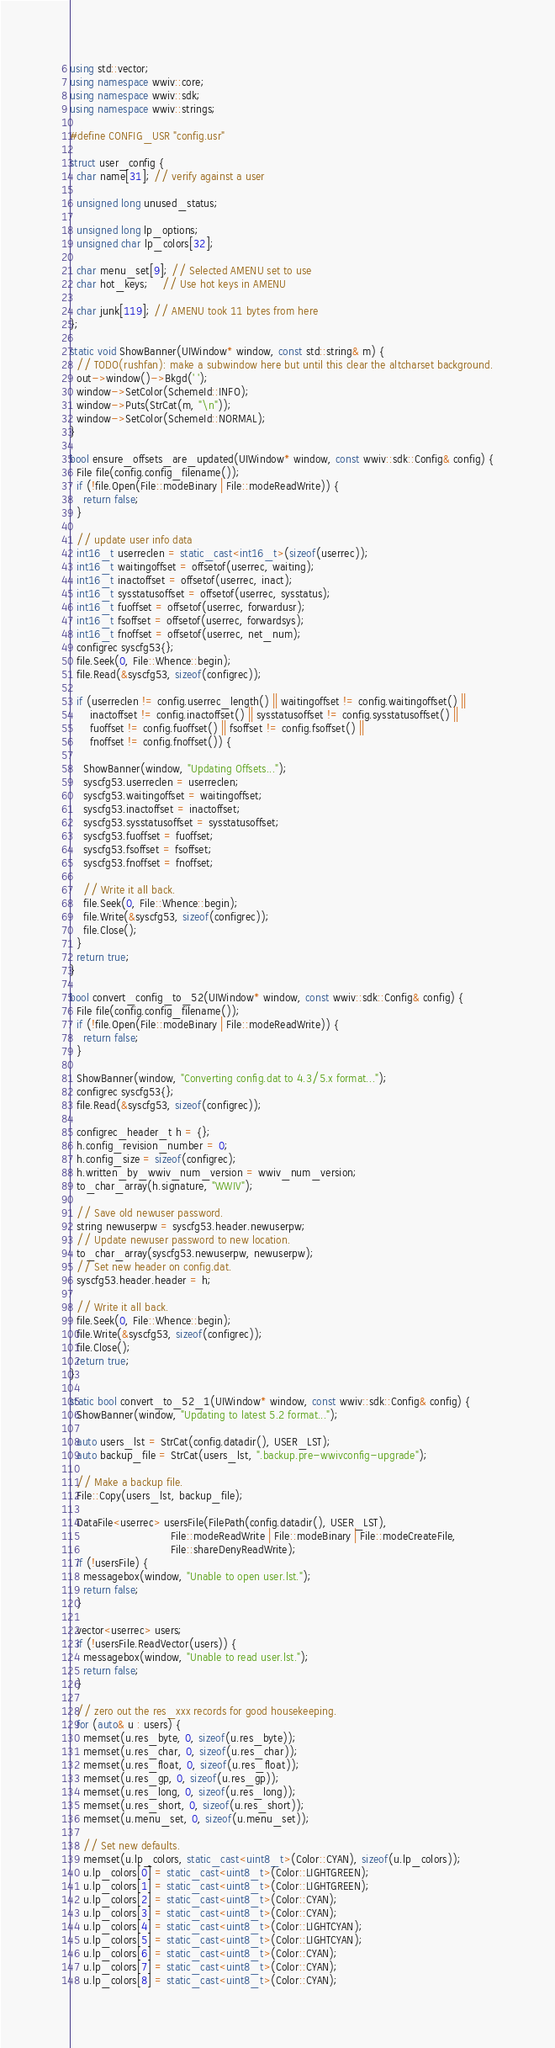<code> <loc_0><loc_0><loc_500><loc_500><_C++_>using std::vector;
using namespace wwiv::core;
using namespace wwiv::sdk;
using namespace wwiv::strings;

#define CONFIG_USR "config.usr"

struct user_config {
  char name[31]; // verify against a user

  unsigned long unused_status;

  unsigned long lp_options;
  unsigned char lp_colors[32];

  char menu_set[9]; // Selected AMENU set to use
  char hot_keys;    // Use hot keys in AMENU

  char junk[119]; // AMENU took 11 bytes from here
};

static void ShowBanner(UIWindow* window, const std::string& m) {
  // TODO(rushfan): make a subwindow here but until this clear the altcharset background.
  out->window()->Bkgd(' ');
  window->SetColor(SchemeId::INFO);
  window->Puts(StrCat(m, "\n"));
  window->SetColor(SchemeId::NORMAL);
}

bool ensure_offsets_are_updated(UIWindow* window, const wwiv::sdk::Config& config) {
  File file(config.config_filename());
  if (!file.Open(File::modeBinary | File::modeReadWrite)) {
    return false;
  }

  // update user info data
  int16_t userreclen = static_cast<int16_t>(sizeof(userrec));
  int16_t waitingoffset = offsetof(userrec, waiting);
  int16_t inactoffset = offsetof(userrec, inact);
  int16_t sysstatusoffset = offsetof(userrec, sysstatus);
  int16_t fuoffset = offsetof(userrec, forwardusr);
  int16_t fsoffset = offsetof(userrec, forwardsys);
  int16_t fnoffset = offsetof(userrec, net_num);
  configrec syscfg53{};
  file.Seek(0, File::Whence::begin);
  file.Read(&syscfg53, sizeof(configrec));

  if (userreclen != config.userrec_length() || waitingoffset != config.waitingoffset() ||
      inactoffset != config.inactoffset() || sysstatusoffset != config.sysstatusoffset() ||
      fuoffset != config.fuoffset() || fsoffset != config.fsoffset() ||
      fnoffset != config.fnoffset()) {

    ShowBanner(window, "Updating Offsets...");
    syscfg53.userreclen = userreclen;
    syscfg53.waitingoffset = waitingoffset;
    syscfg53.inactoffset = inactoffset;
    syscfg53.sysstatusoffset = sysstatusoffset;
    syscfg53.fuoffset = fuoffset;
    syscfg53.fsoffset = fsoffset;
    syscfg53.fnoffset = fnoffset;

    // Write it all back.
    file.Seek(0, File::Whence::begin);
    file.Write(&syscfg53, sizeof(configrec));
    file.Close();
  }
  return true;
}

bool convert_config_to_52(UIWindow* window, const wwiv::sdk::Config& config) {
  File file(config.config_filename());
  if (!file.Open(File::modeBinary | File::modeReadWrite)) {
    return false;
  }

  ShowBanner(window, "Converting config.dat to 4.3/5.x format...");
  configrec syscfg53{};
  file.Read(&syscfg53, sizeof(configrec));

  configrec_header_t h = {};
  h.config_revision_number = 0;
  h.config_size = sizeof(configrec);
  h.written_by_wwiv_num_version = wwiv_num_version;
  to_char_array(h.signature, "WWIV");

  // Save old newuser password.
  string newuserpw = syscfg53.header.newuserpw;
  // Update newuser password to new location.
  to_char_array(syscfg53.newuserpw, newuserpw);
  // Set new header on config.dat.
  syscfg53.header.header = h;

  // Write it all back.
  file.Seek(0, File::Whence::begin);
  file.Write(&syscfg53, sizeof(configrec));
  file.Close();
  return true;
}

static bool convert_to_52_1(UIWindow* window, const wwiv::sdk::Config& config) {
  ShowBanner(window, "Updating to latest 5.2 format...");

  auto users_lst = StrCat(config.datadir(), USER_LST);
  auto backup_file = StrCat(users_lst, ".backup.pre-wwivconfig-upgrade");

  // Make a backup file.
  File::Copy(users_lst, backup_file);

  DataFile<userrec> usersFile(FilePath(config.datadir(), USER_LST),
                              File::modeReadWrite | File::modeBinary | File::modeCreateFile,
                              File::shareDenyReadWrite);
  if (!usersFile) {
    messagebox(window, "Unable to open user.lst.");
    return false;
  }

  vector<userrec> users;
  if (!usersFile.ReadVector(users)) {
    messagebox(window, "Unable to read user.lst.");
    return false;
  }

  // zero out the res_xxx records for good housekeeping.
  for (auto& u : users) {
    memset(u.res_byte, 0, sizeof(u.res_byte));
    memset(u.res_char, 0, sizeof(u.res_char));
    memset(u.res_float, 0, sizeof(u.res_float));
    memset(u.res_gp, 0, sizeof(u.res_gp));
    memset(u.res_long, 0, sizeof(u.res_long));
    memset(u.res_short, 0, sizeof(u.res_short));
    memset(u.menu_set, 0, sizeof(u.menu_set));

    // Set new defaults.
    memset(u.lp_colors, static_cast<uint8_t>(Color::CYAN), sizeof(u.lp_colors));
    u.lp_colors[0] = static_cast<uint8_t>(Color::LIGHTGREEN);
    u.lp_colors[1] = static_cast<uint8_t>(Color::LIGHTGREEN);
    u.lp_colors[2] = static_cast<uint8_t>(Color::CYAN);
    u.lp_colors[3] = static_cast<uint8_t>(Color::CYAN);
    u.lp_colors[4] = static_cast<uint8_t>(Color::LIGHTCYAN);
    u.lp_colors[5] = static_cast<uint8_t>(Color::LIGHTCYAN);
    u.lp_colors[6] = static_cast<uint8_t>(Color::CYAN);
    u.lp_colors[7] = static_cast<uint8_t>(Color::CYAN);
    u.lp_colors[8] = static_cast<uint8_t>(Color::CYAN);</code> 